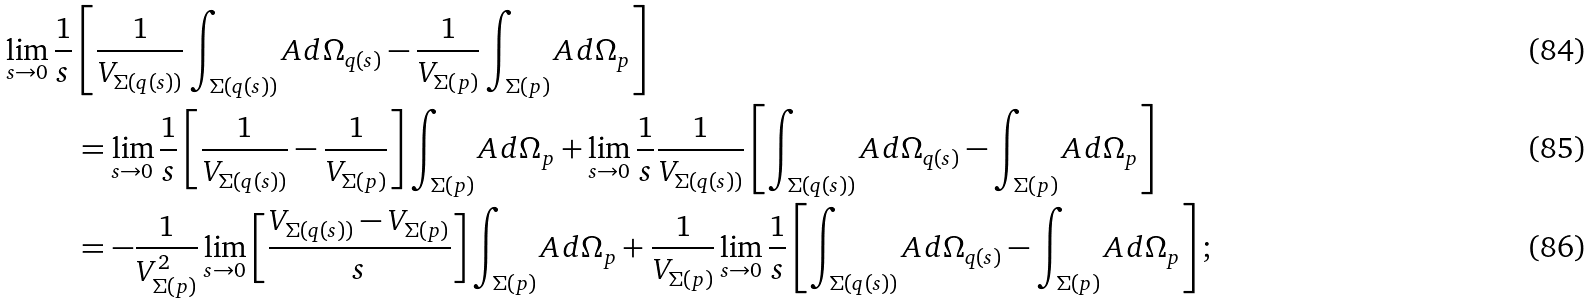<formula> <loc_0><loc_0><loc_500><loc_500>\lim _ { s \to 0 } \frac { 1 } { s } & \left [ \frac { 1 } { V _ { \Sigma ( q ( s ) ) } } \int _ { \Sigma ( q ( s ) ) } A \, d \Omega _ { q ( s ) } - \frac { 1 } { V _ { \Sigma ( p ) } } \int _ { \Sigma ( p ) } A \, d \Omega _ { p } \right ] \\ & = \lim _ { s \to 0 } \frac { 1 } { s } \left [ \frac { 1 } { V _ { \Sigma ( q ( s ) ) } } - \frac { 1 } { V _ { \Sigma ( p ) } } \right ] \int _ { \Sigma ( p ) } A \, d \Omega _ { p } + \lim _ { s \to 0 } \frac { 1 } { s } \frac { 1 } { V _ { \Sigma ( q ( s ) ) } } \left [ \int _ { \Sigma ( q ( s ) ) } A \, d \Omega _ { q ( s ) } - \int _ { \Sigma ( p ) } A \, d \Omega _ { p } \right ] \\ & = - \frac { 1 } { V _ { \Sigma ( p ) } ^ { 2 } } \lim _ { s \to 0 } \left [ \frac { V _ { \Sigma ( q ( s ) ) } - V _ { \Sigma ( p ) } } { s } \right ] \int _ { \Sigma ( p ) } A \, d \Omega _ { p } + \frac { 1 } { V _ { \Sigma ( p ) } } \lim _ { s \to 0 } \frac { 1 } { s } \left [ \int _ { \Sigma ( q ( s ) ) } A \, d \Omega _ { q ( s ) } - \int _ { \Sigma ( p ) } A \, d \Omega _ { p } \right ] ;</formula> 